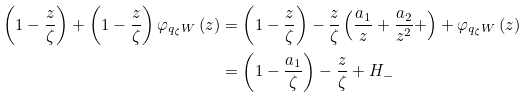<formula> <loc_0><loc_0><loc_500><loc_500>\left ( 1 - \frac { z } { \zeta } \right ) + \left ( 1 - \frac { z } { \zeta } \right ) \varphi _ { q _ { \zeta } W } \left ( z \right ) & = \left ( 1 - \frac { z } { \zeta } \right ) - \frac { z } { \zeta } \left ( \frac { a _ { 1 } } { z } + \frac { a _ { 2 } } { z ^ { 2 } } + \right ) + \varphi _ { q _ { \zeta } W } \left ( z \right ) \\ & = \left ( 1 - \frac { a _ { 1 } } { \zeta } \right ) - \frac { z } { \zeta } + H _ { - }</formula> 